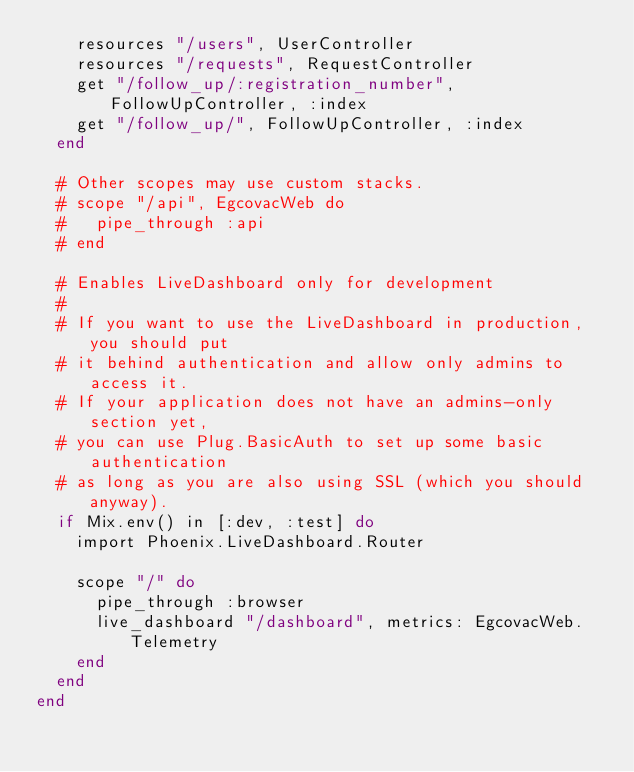Convert code to text. <code><loc_0><loc_0><loc_500><loc_500><_Elixir_>    resources "/users", UserController
    resources "/requests", RequestController
    get "/follow_up/:registration_number", FollowUpController, :index
    get "/follow_up/", FollowUpController, :index
  end

  # Other scopes may use custom stacks.
  # scope "/api", EgcovacWeb do
  #   pipe_through :api
  # end

  # Enables LiveDashboard only for development
  #
  # If you want to use the LiveDashboard in production, you should put
  # it behind authentication and allow only admins to access it.
  # If your application does not have an admins-only section yet,
  # you can use Plug.BasicAuth to set up some basic authentication
  # as long as you are also using SSL (which you should anyway).
  if Mix.env() in [:dev, :test] do
    import Phoenix.LiveDashboard.Router

    scope "/" do
      pipe_through :browser
      live_dashboard "/dashboard", metrics: EgcovacWeb.Telemetry
    end
  end
end
</code> 